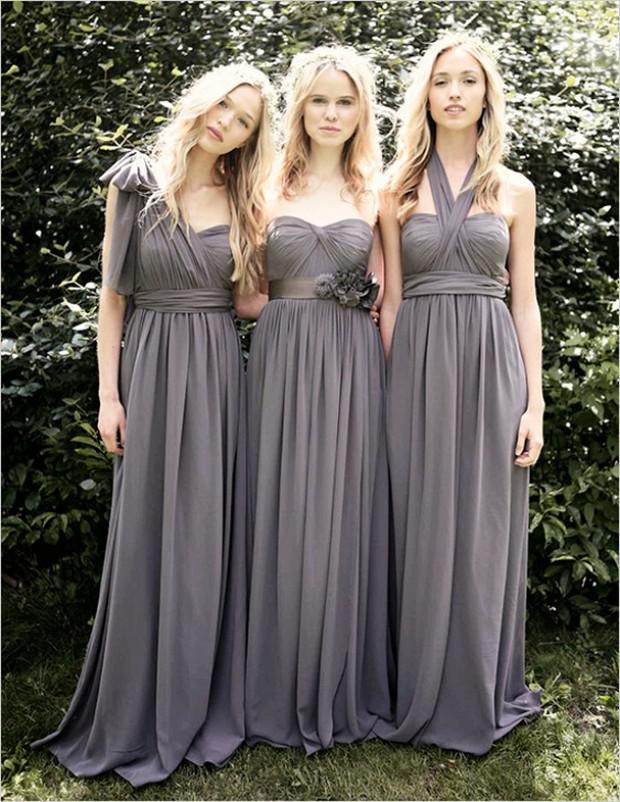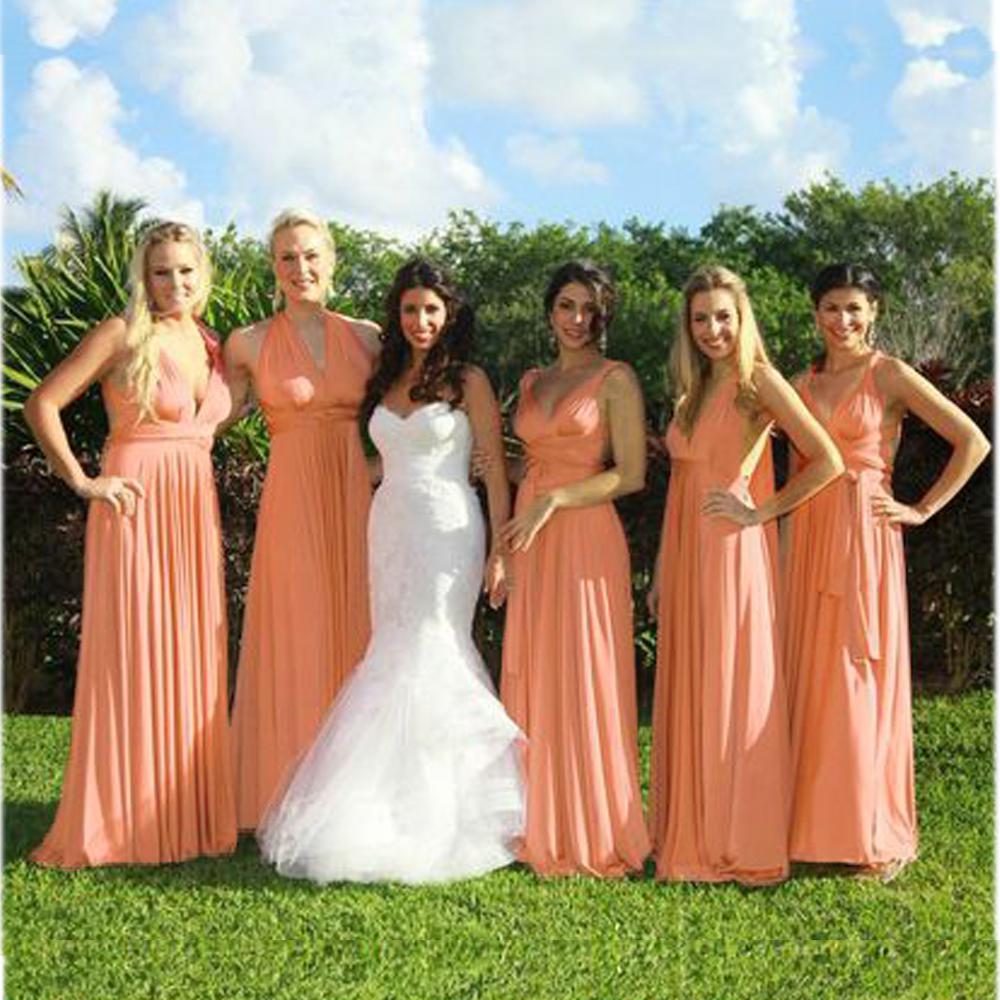The first image is the image on the left, the second image is the image on the right. Given the left and right images, does the statement "In one image, exactly four women are shown standing in a row." hold true? Answer yes or no. No. The first image is the image on the left, the second image is the image on the right. For the images displayed, is the sentence "There are three women in the left image" factually correct? Answer yes or no. Yes. 